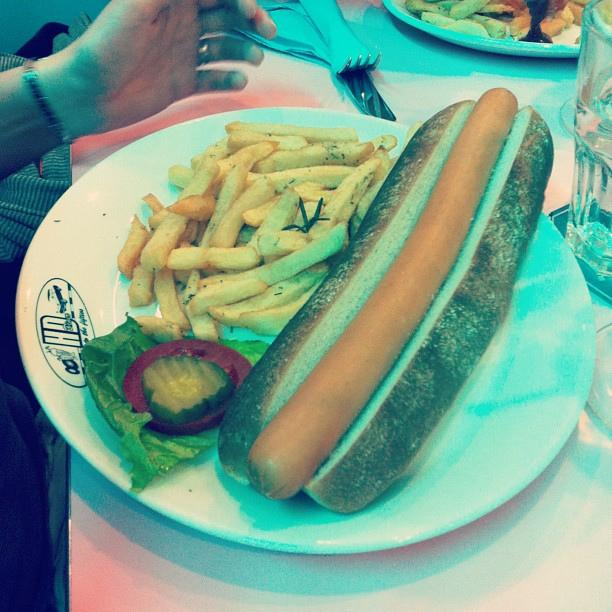Why might this longest food be unappealing to some? meat product 